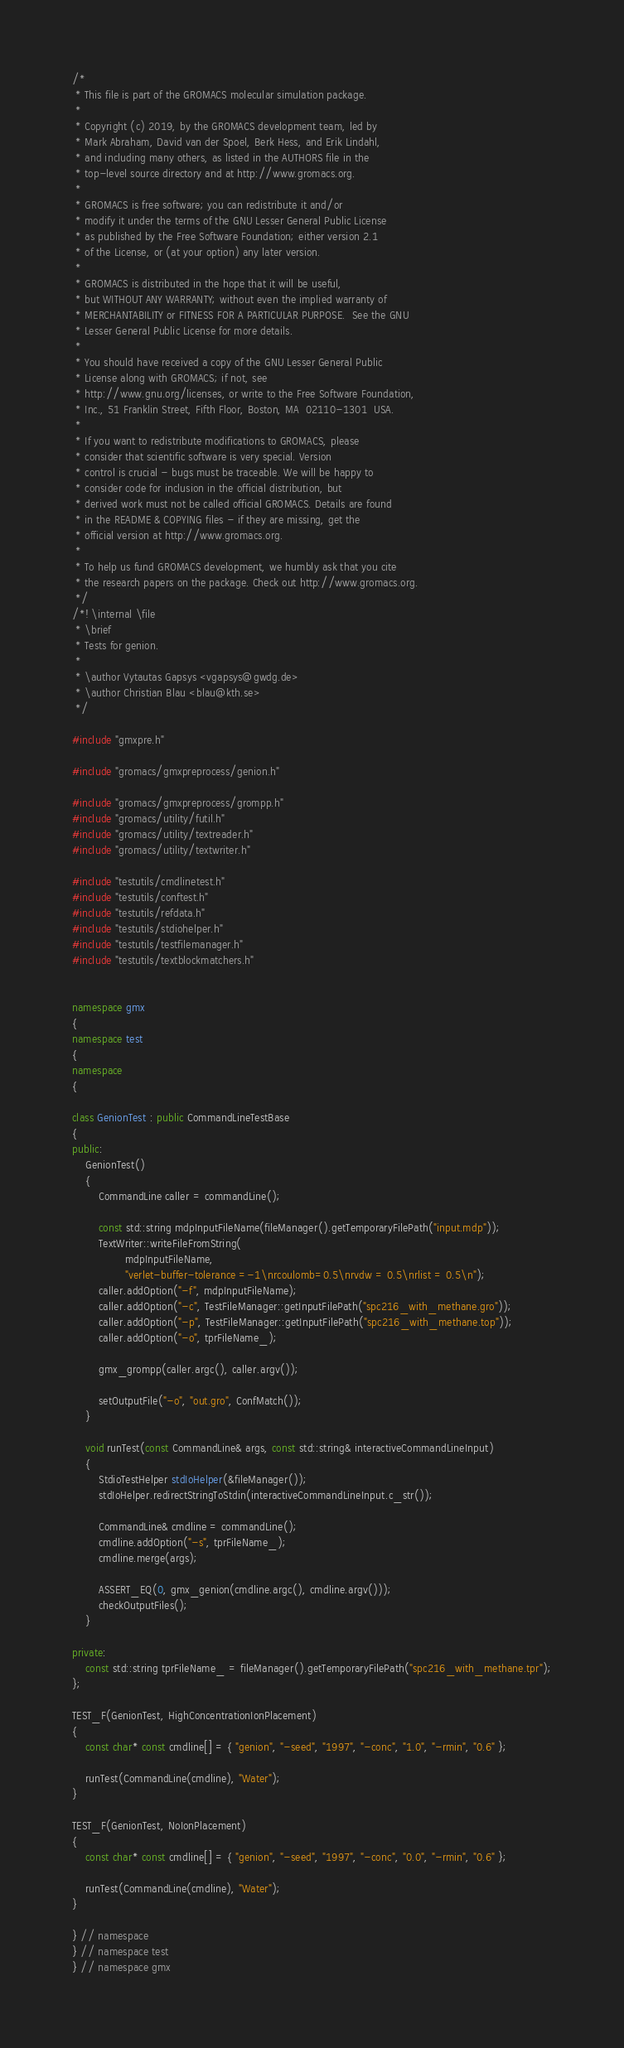Convert code to text. <code><loc_0><loc_0><loc_500><loc_500><_C++_>/*
 * This file is part of the GROMACS molecular simulation package.
 *
 * Copyright (c) 2019, by the GROMACS development team, led by
 * Mark Abraham, David van der Spoel, Berk Hess, and Erik Lindahl,
 * and including many others, as listed in the AUTHORS file in the
 * top-level source directory and at http://www.gromacs.org.
 *
 * GROMACS is free software; you can redistribute it and/or
 * modify it under the terms of the GNU Lesser General Public License
 * as published by the Free Software Foundation; either version 2.1
 * of the License, or (at your option) any later version.
 *
 * GROMACS is distributed in the hope that it will be useful,
 * but WITHOUT ANY WARRANTY; without even the implied warranty of
 * MERCHANTABILITY or FITNESS FOR A PARTICULAR PURPOSE.  See the GNU
 * Lesser General Public License for more details.
 *
 * You should have received a copy of the GNU Lesser General Public
 * License along with GROMACS; if not, see
 * http://www.gnu.org/licenses, or write to the Free Software Foundation,
 * Inc., 51 Franklin Street, Fifth Floor, Boston, MA  02110-1301  USA.
 *
 * If you want to redistribute modifications to GROMACS, please
 * consider that scientific software is very special. Version
 * control is crucial - bugs must be traceable. We will be happy to
 * consider code for inclusion in the official distribution, but
 * derived work must not be called official GROMACS. Details are found
 * in the README & COPYING files - if they are missing, get the
 * official version at http://www.gromacs.org.
 *
 * To help us fund GROMACS development, we humbly ask that you cite
 * the research papers on the package. Check out http://www.gromacs.org.
 */
/*! \internal \file
 * \brief
 * Tests for genion.
 *
 * \author Vytautas Gapsys <vgapsys@gwdg.de>
 * \author Christian Blau <blau@kth.se>
 */

#include "gmxpre.h"

#include "gromacs/gmxpreprocess/genion.h"

#include "gromacs/gmxpreprocess/grompp.h"
#include "gromacs/utility/futil.h"
#include "gromacs/utility/textreader.h"
#include "gromacs/utility/textwriter.h"

#include "testutils/cmdlinetest.h"
#include "testutils/conftest.h"
#include "testutils/refdata.h"
#include "testutils/stdiohelper.h"
#include "testutils/testfilemanager.h"
#include "testutils/textblockmatchers.h"


namespace gmx
{
namespace test
{
namespace
{

class GenionTest : public CommandLineTestBase
{
public:
    GenionTest()
    {
        CommandLine caller = commandLine();

        const std::string mdpInputFileName(fileManager().getTemporaryFilePath("input.mdp"));
        TextWriter::writeFileFromString(
                mdpInputFileName,
                "verlet-buffer-tolerance =-1\nrcoulomb=0.5\nrvdw = 0.5\nrlist = 0.5\n");
        caller.addOption("-f", mdpInputFileName);
        caller.addOption("-c", TestFileManager::getInputFilePath("spc216_with_methane.gro"));
        caller.addOption("-p", TestFileManager::getInputFilePath("spc216_with_methane.top"));
        caller.addOption("-o", tprFileName_);

        gmx_grompp(caller.argc(), caller.argv());

        setOutputFile("-o", "out.gro", ConfMatch());
    }

    void runTest(const CommandLine& args, const std::string& interactiveCommandLineInput)
    {
        StdioTestHelper stdIoHelper(&fileManager());
        stdIoHelper.redirectStringToStdin(interactiveCommandLineInput.c_str());

        CommandLine& cmdline = commandLine();
        cmdline.addOption("-s", tprFileName_);
        cmdline.merge(args);

        ASSERT_EQ(0, gmx_genion(cmdline.argc(), cmdline.argv()));
        checkOutputFiles();
    }

private:
    const std::string tprFileName_ = fileManager().getTemporaryFilePath("spc216_with_methane.tpr");
};

TEST_F(GenionTest, HighConcentrationIonPlacement)
{
    const char* const cmdline[] = { "genion", "-seed", "1997", "-conc", "1.0", "-rmin", "0.6" };

    runTest(CommandLine(cmdline), "Water");
}

TEST_F(GenionTest, NoIonPlacement)
{
    const char* const cmdline[] = { "genion", "-seed", "1997", "-conc", "0.0", "-rmin", "0.6" };

    runTest(CommandLine(cmdline), "Water");
}

} // namespace
} // namespace test
} // namespace gmx
</code> 